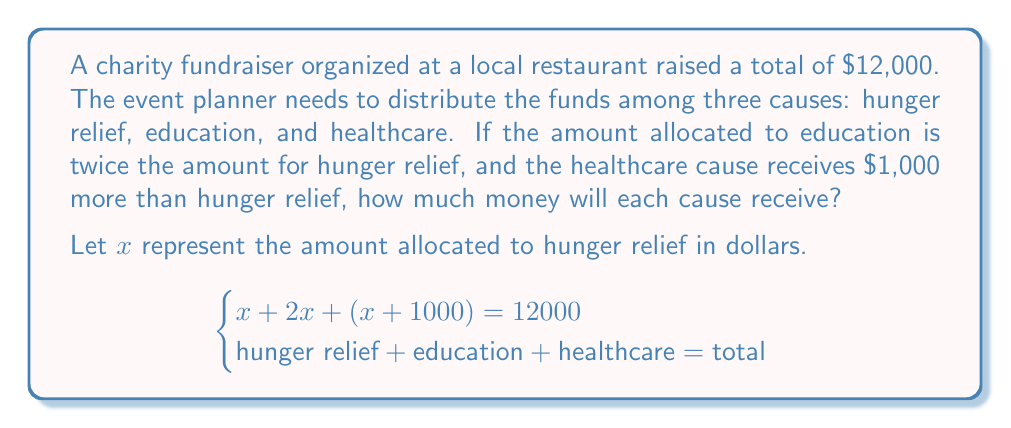Can you answer this question? To solve this problem, we'll use a system of equations approach:

1. Set up the equation based on the given information:
   $x + 2x + (x + 1000) = 12000$

2. Simplify the left side of the equation:
   $4x + 1000 = 12000$

3. Subtract 1000 from both sides:
   $4x = 11000$

4. Divide both sides by 4:
   $x = 2750$

5. Now that we know $x$ (hunger relief), we can calculate the other amounts:
   - Education: $2x = 2(2750) = 5500$
   - Healthcare: $x + 1000 = 2750 + 1000 = 3750$

6. Verify the total:
   $2750 + 5500 + 3750 = 12000$

Therefore, hunger relief will receive $2,750, education will receive $5,500, and healthcare will receive $3,750.
Answer: Hunger relief: $2,750
Education: $5,500
Healthcare: $3,750 